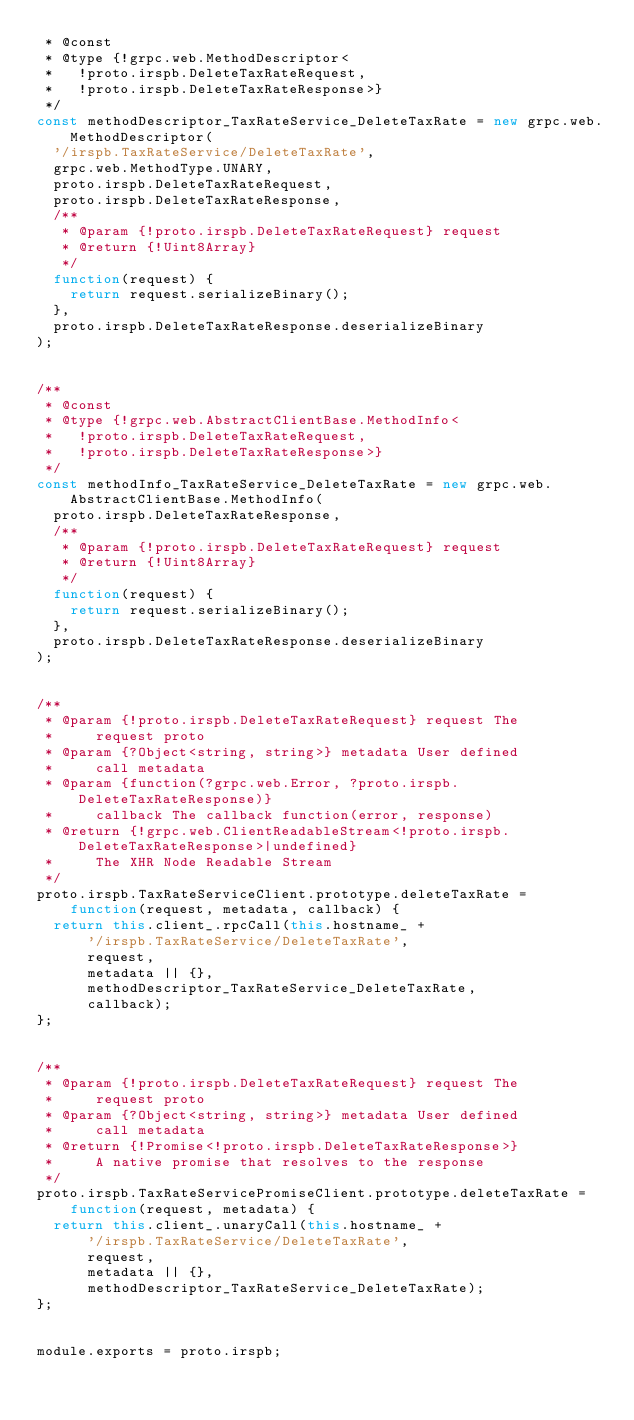Convert code to text. <code><loc_0><loc_0><loc_500><loc_500><_JavaScript_> * @const
 * @type {!grpc.web.MethodDescriptor<
 *   !proto.irspb.DeleteTaxRateRequest,
 *   !proto.irspb.DeleteTaxRateResponse>}
 */
const methodDescriptor_TaxRateService_DeleteTaxRate = new grpc.web.MethodDescriptor(
  '/irspb.TaxRateService/DeleteTaxRate',
  grpc.web.MethodType.UNARY,
  proto.irspb.DeleteTaxRateRequest,
  proto.irspb.DeleteTaxRateResponse,
  /**
   * @param {!proto.irspb.DeleteTaxRateRequest} request
   * @return {!Uint8Array}
   */
  function(request) {
    return request.serializeBinary();
  },
  proto.irspb.DeleteTaxRateResponse.deserializeBinary
);


/**
 * @const
 * @type {!grpc.web.AbstractClientBase.MethodInfo<
 *   !proto.irspb.DeleteTaxRateRequest,
 *   !proto.irspb.DeleteTaxRateResponse>}
 */
const methodInfo_TaxRateService_DeleteTaxRate = new grpc.web.AbstractClientBase.MethodInfo(
  proto.irspb.DeleteTaxRateResponse,
  /**
   * @param {!proto.irspb.DeleteTaxRateRequest} request
   * @return {!Uint8Array}
   */
  function(request) {
    return request.serializeBinary();
  },
  proto.irspb.DeleteTaxRateResponse.deserializeBinary
);


/**
 * @param {!proto.irspb.DeleteTaxRateRequest} request The
 *     request proto
 * @param {?Object<string, string>} metadata User defined
 *     call metadata
 * @param {function(?grpc.web.Error, ?proto.irspb.DeleteTaxRateResponse)}
 *     callback The callback function(error, response)
 * @return {!grpc.web.ClientReadableStream<!proto.irspb.DeleteTaxRateResponse>|undefined}
 *     The XHR Node Readable Stream
 */
proto.irspb.TaxRateServiceClient.prototype.deleteTaxRate =
    function(request, metadata, callback) {
  return this.client_.rpcCall(this.hostname_ +
      '/irspb.TaxRateService/DeleteTaxRate',
      request,
      metadata || {},
      methodDescriptor_TaxRateService_DeleteTaxRate,
      callback);
};


/**
 * @param {!proto.irspb.DeleteTaxRateRequest} request The
 *     request proto
 * @param {?Object<string, string>} metadata User defined
 *     call metadata
 * @return {!Promise<!proto.irspb.DeleteTaxRateResponse>}
 *     A native promise that resolves to the response
 */
proto.irspb.TaxRateServicePromiseClient.prototype.deleteTaxRate =
    function(request, metadata) {
  return this.client_.unaryCall(this.hostname_ +
      '/irspb.TaxRateService/DeleteTaxRate',
      request,
      metadata || {},
      methodDescriptor_TaxRateService_DeleteTaxRate);
};


module.exports = proto.irspb;

</code> 